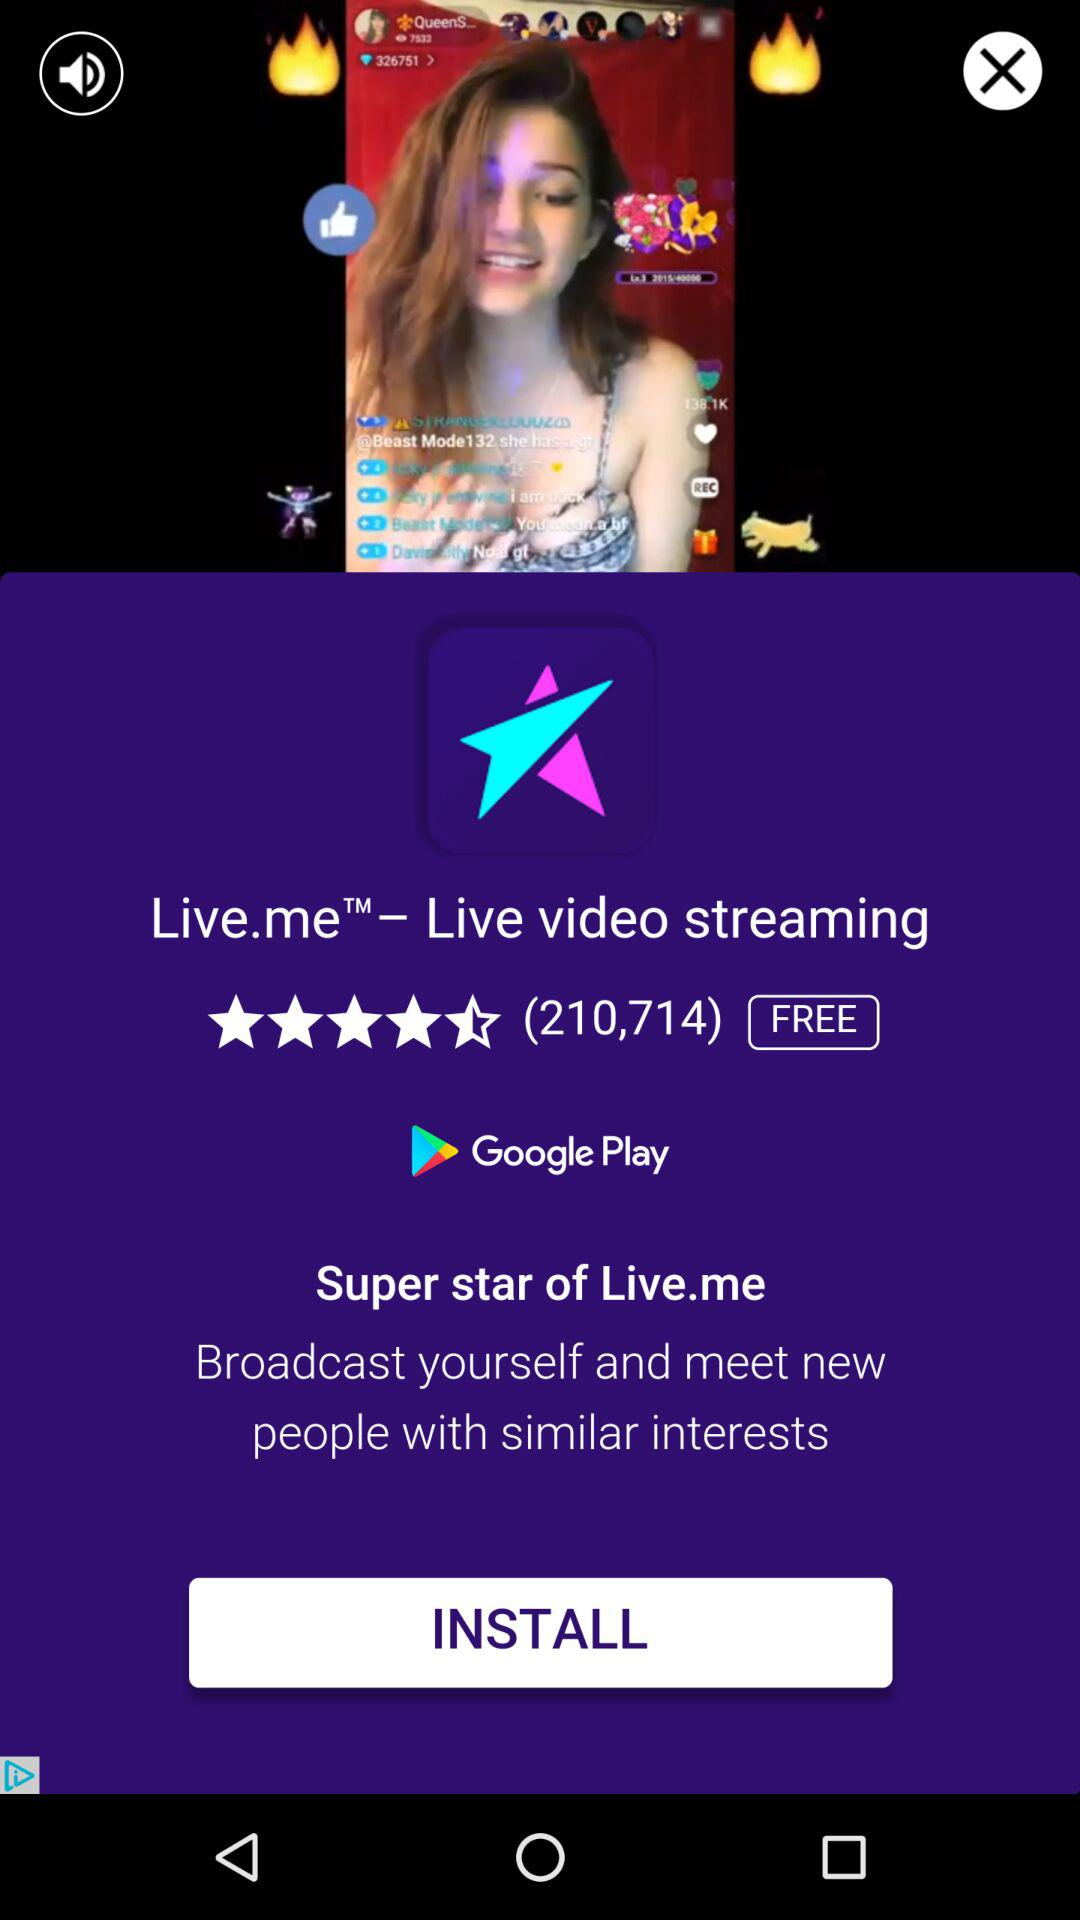How many reviews does the app have?
Answer the question using a single word or phrase. 210,714 